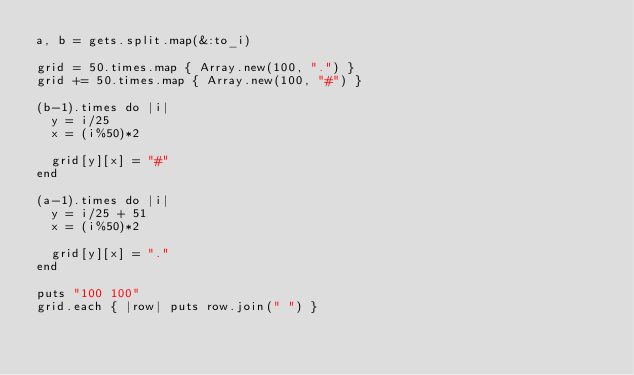Convert code to text. <code><loc_0><loc_0><loc_500><loc_500><_Ruby_>a, b = gets.split.map(&:to_i)

grid = 50.times.map { Array.new(100, ".") }
grid += 50.times.map { Array.new(100, "#") }

(b-1).times do |i|
  y = i/25
  x = (i%50)*2

  grid[y][x] = "#"
end

(a-1).times do |i|
  y = i/25 + 51
  x = (i%50)*2

  grid[y][x] = "."
end

puts "100 100"
grid.each { |row| puts row.join(" ") }
</code> 